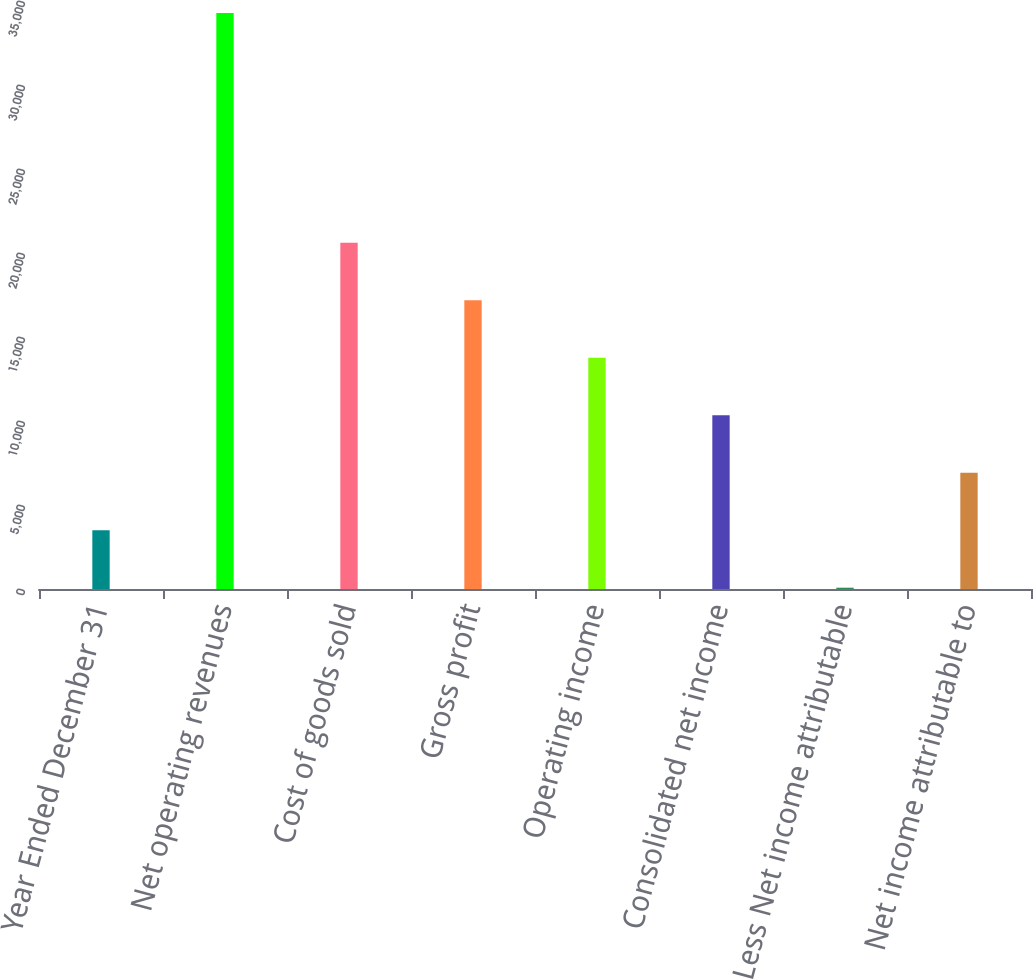Convert chart to OTSL. <chart><loc_0><loc_0><loc_500><loc_500><bar_chart><fcel>Year Ended December 31<fcel>Net operating revenues<fcel>Cost of goods sold<fcel>Gross profit<fcel>Operating income<fcel>Consolidated net income<fcel>Less Net income attributable<fcel>Net income attributable to<nl><fcel>3499.4<fcel>34292<fcel>20606.4<fcel>17185<fcel>13763.6<fcel>10342.2<fcel>78<fcel>6920.8<nl></chart> 